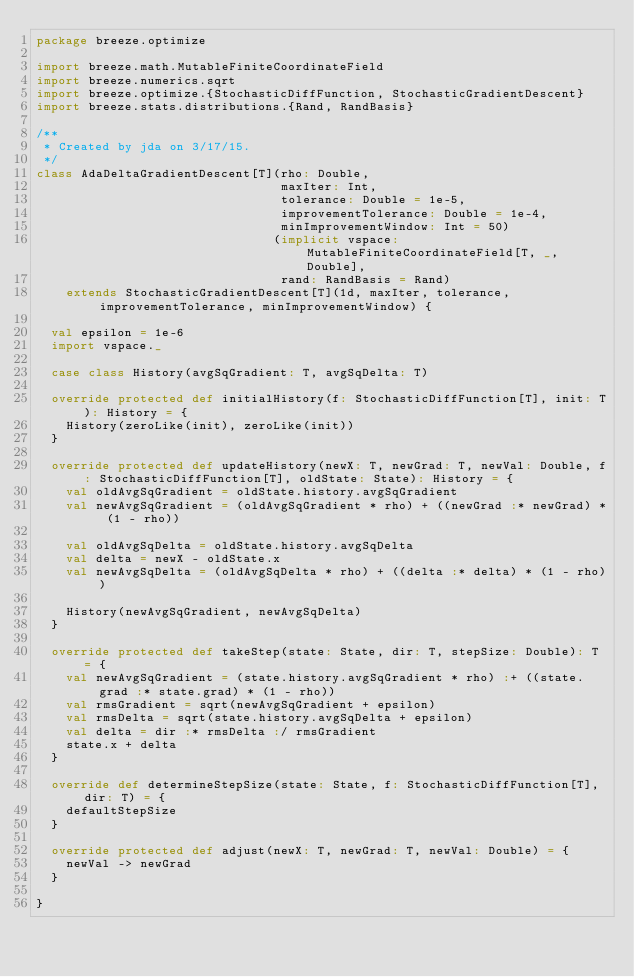Convert code to text. <code><loc_0><loc_0><loc_500><loc_500><_Scala_>package breeze.optimize

import breeze.math.MutableFiniteCoordinateField
import breeze.numerics.sqrt
import breeze.optimize.{StochasticDiffFunction, StochasticGradientDescent}
import breeze.stats.distributions.{Rand, RandBasis}

/**
 * Created by jda on 3/17/15.
 */
class AdaDeltaGradientDescent[T](rho: Double,
                                 maxIter: Int,
                                 tolerance: Double = 1e-5,
                                 improvementTolerance: Double = 1e-4,
                                 minImprovementWindow: Int = 50)
                                (implicit vspace: MutableFiniteCoordinateField[T, _, Double],
                                 rand: RandBasis = Rand)
    extends StochasticGradientDescent[T](1d, maxIter, tolerance, improvementTolerance, minImprovementWindow) {

  val epsilon = 1e-6
  import vspace._

  case class History(avgSqGradient: T, avgSqDelta: T)

  override protected def initialHistory(f: StochasticDiffFunction[T], init: T): History = {
    History(zeroLike(init), zeroLike(init))
  }

  override protected def updateHistory(newX: T, newGrad: T, newVal: Double, f: StochasticDiffFunction[T], oldState: State): History = {
    val oldAvgSqGradient = oldState.history.avgSqGradient
    val newAvgSqGradient = (oldAvgSqGradient * rho) + ((newGrad :* newGrad) * (1 - rho))

    val oldAvgSqDelta = oldState.history.avgSqDelta
    val delta = newX - oldState.x
    val newAvgSqDelta = (oldAvgSqDelta * rho) + ((delta :* delta) * (1 - rho))

    History(newAvgSqGradient, newAvgSqDelta)
  }

  override protected def takeStep(state: State, dir: T, stepSize: Double): T = {
    val newAvgSqGradient = (state.history.avgSqGradient * rho) :+ ((state.grad :* state.grad) * (1 - rho))
    val rmsGradient = sqrt(newAvgSqGradient + epsilon)
    val rmsDelta = sqrt(state.history.avgSqDelta + epsilon)
    val delta = dir :* rmsDelta :/ rmsGradient
    state.x + delta
  }

  override def determineStepSize(state: State, f: StochasticDiffFunction[T], dir: T) = {
    defaultStepSize
  }

  override protected def adjust(newX: T, newGrad: T, newVal: Double) = {
    newVal -> newGrad
  }

}
</code> 